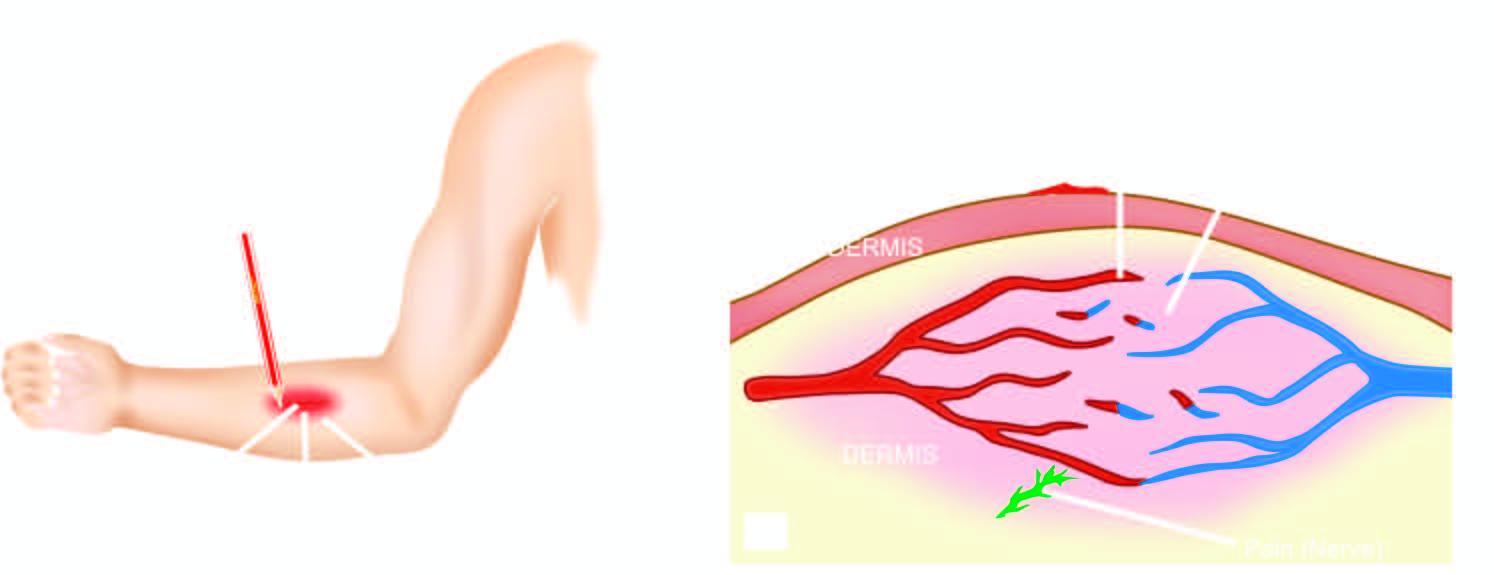s 'triple response ' elicited by firm stroking of skin of forearm with a pencil?
Answer the question using a single word or phrase. Yes 